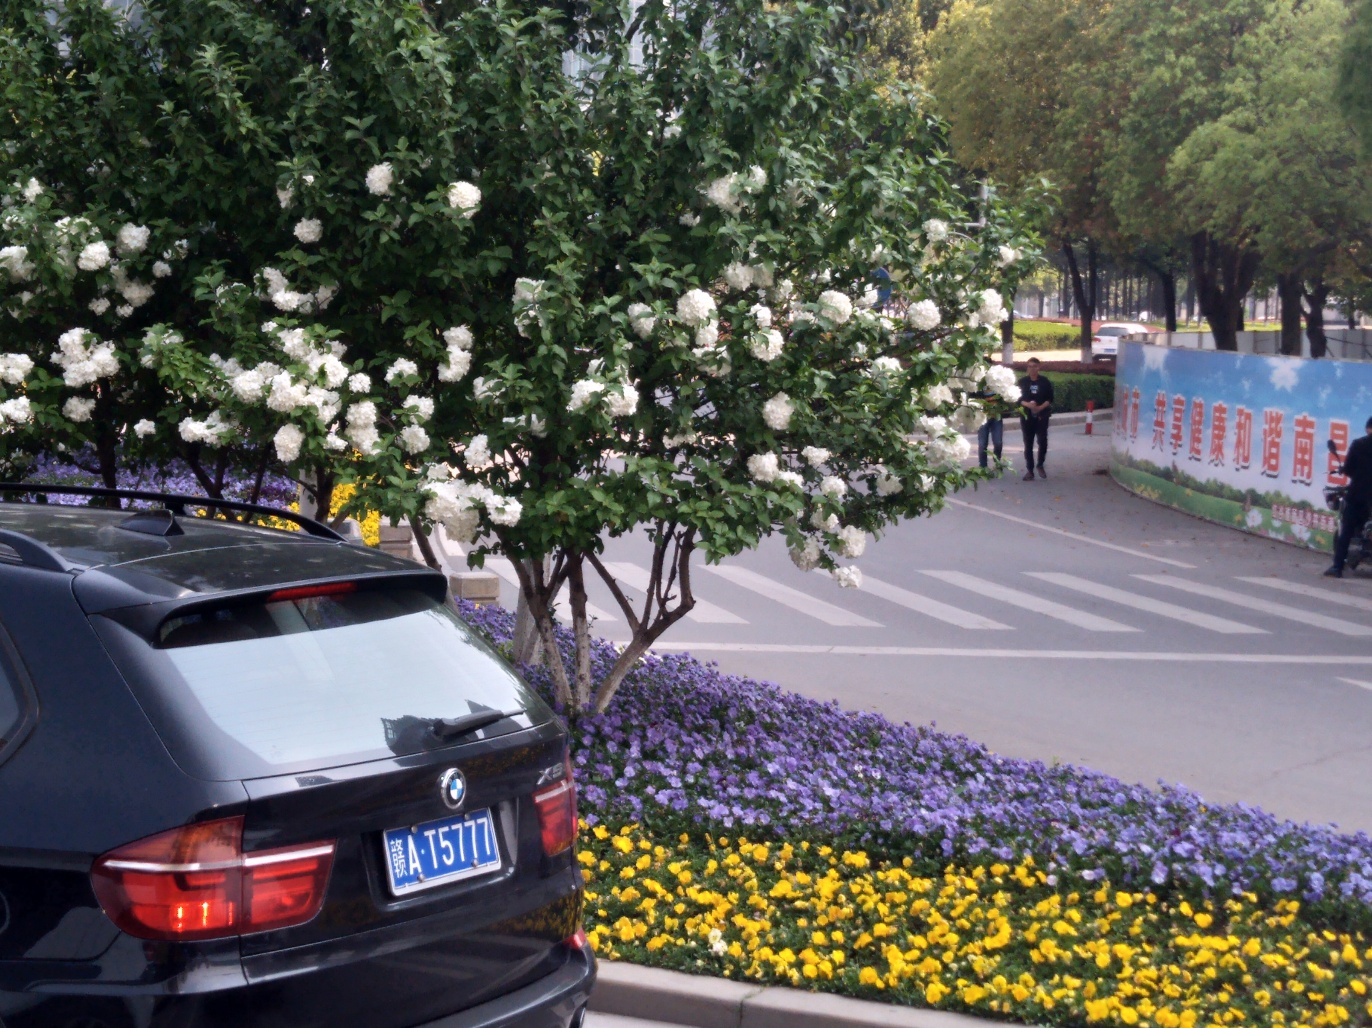Is the lighting sufficient in the image? Yes, the lighting in the image is sufficient for clear visibility. It appears to be an overcast day with diffuse natural light that allows for the details of the blooming flowers, the parked car, and the figures in the background to be seen without harsh shadows or glare. 